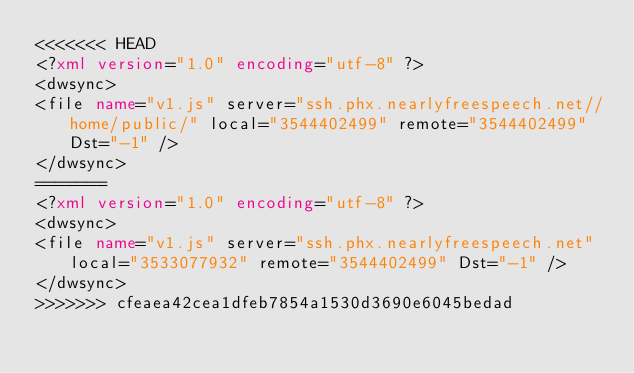<code> <loc_0><loc_0><loc_500><loc_500><_XML_><<<<<<< HEAD
<?xml version="1.0" encoding="utf-8" ?><dwsync><file name="v1.js" server="ssh.phx.nearlyfreespeech.net//home/public/" local="3544402499" remote="3544402499" Dst="-1" /></dwsync>
=======
<?xml version="1.0" encoding="utf-8" ?><dwsync><file name="v1.js" server="ssh.phx.nearlyfreespeech.net" local="3533077932" remote="3544402499" Dst="-1" /></dwsync>
>>>>>>> cfeaea42cea1dfeb7854a1530d3690e6045bedad
</code> 